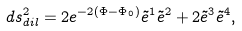<formula> <loc_0><loc_0><loc_500><loc_500>d s _ { d i l } ^ { 2 } = 2 e ^ { - 2 ( \Phi - { \Phi } _ { 0 } ) } { \tilde { e } } ^ { 1 } { \tilde { e } } ^ { 2 } + 2 { \tilde { e } } ^ { 3 } { \tilde { e } } ^ { 4 } ,</formula> 